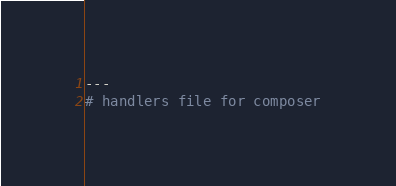<code> <loc_0><loc_0><loc_500><loc_500><_YAML_>---
# handlers file for composer</code> 